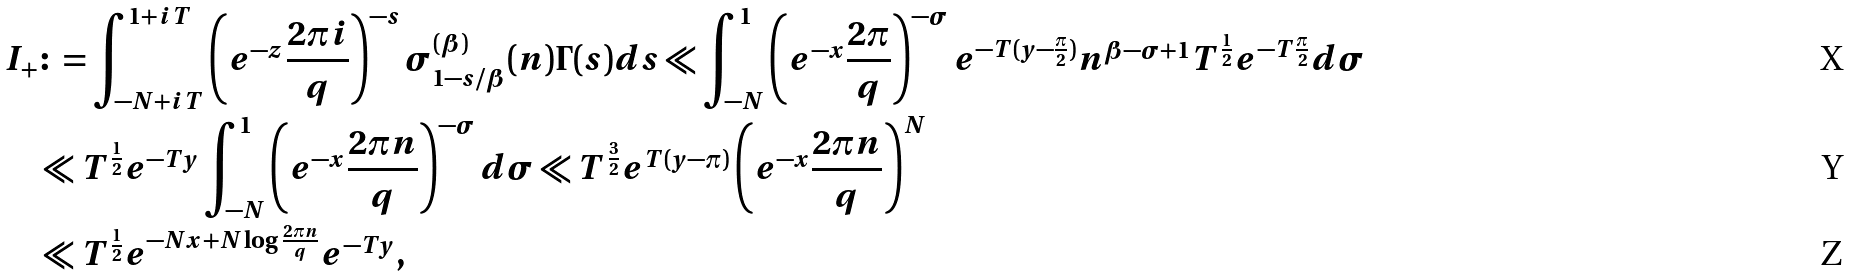<formula> <loc_0><loc_0><loc_500><loc_500>I _ { + } & \colon = \int _ { - N + i T } ^ { 1 + i T } \left ( e ^ { - z } \frac { 2 \pi i } { q } \right ) ^ { - s } \sigma _ { 1 - s / \beta } ^ { ( \beta ) } ( n ) \Gamma ( s ) d s \ll \int _ { - N } ^ { 1 } \left ( e ^ { - x } \frac { 2 \pi } { q } \right ) ^ { - \sigma } e ^ { - T ( y - \frac { \pi } { 2 } ) } n ^ { \beta - \sigma + 1 } T ^ { \frac { 1 } { 2 } } e ^ { - T \frac { \pi } { 2 } } d \sigma \\ & \ll T ^ { \frac { 1 } { 2 } } e ^ { - T y } \int _ { - N } ^ { 1 } \left ( e ^ { - x } \frac { 2 \pi n } { q } \right ) ^ { - \sigma } d \sigma \ll T ^ { \frac { 3 } { 2 } } e ^ { T ( y - \pi ) } \left ( e ^ { - x } \frac { 2 \pi n } { q } \right ) ^ { N } \\ & \ll T ^ { \frac { 1 } { 2 } } e ^ { - N x + N \log \frac { 2 \pi n } { q } } e ^ { - T y } ,</formula> 